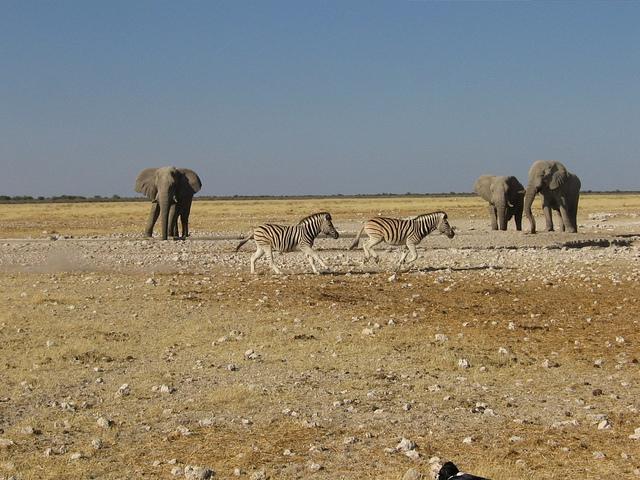Are there any green plants here?
Short answer required. No. How many animals are running?
Write a very short answer. 2. How many different types of animals are there?
Keep it brief. 2. Do these animals appear to be in a zoo?
Write a very short answer. No. Is it a cloudy day?
Give a very brief answer. No. Are the zebras in a zoo?
Write a very short answer. No. 